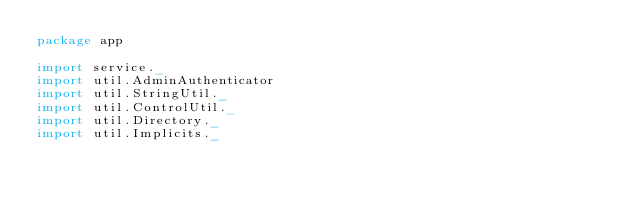<code> <loc_0><loc_0><loc_500><loc_500><_Scala_>package app

import service._
import util.AdminAuthenticator
import util.StringUtil._
import util.ControlUtil._
import util.Directory._
import util.Implicits._</code> 